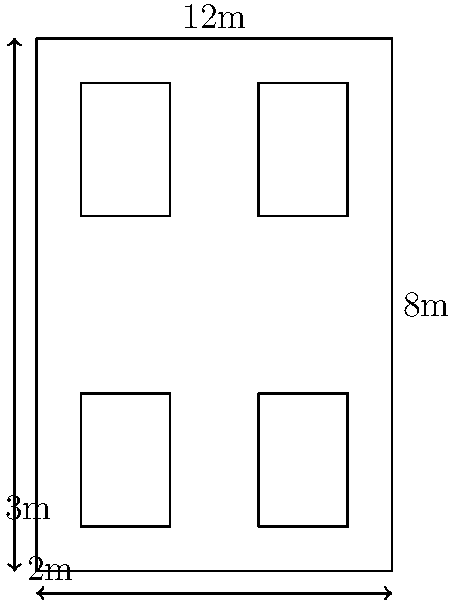A rectangular kitchen measures 8m by 12m. You need to place four identical rectangular workstations, each measuring 2m by 3m. What is the maximum possible distance between the centers of any two workstations, assuming they are placed parallel to the kitchen walls and at least 1m away from any wall? To solve this problem, we'll follow these steps:

1) First, we need to understand the constraints:
   - Kitchen dimensions: 8m x 12m
   - Workstation dimensions: 2m x 3m
   - Minimum distance from walls: 1m

2) Given these constraints, the workstations can be placed in the following coordinates:
   - Workstation 1: (1,1) to (3,4)
   - Workstation 2: (5,1) to (7,4)
   - Workstation 3: (1,8) to (3,11)
   - Workstation 4: (5,8) to (7,11)

3) The centers of these workstations will be at:
   - C1: (2,2.5)
   - C2: (6,2.5)
   - C3: (2,9.5)
   - C4: (6,9.5)

4) To find the maximum distance, we need to calculate the distance between the farthest points. This will be either C1 to C4 or C2 to C3.

5) We can use the distance formula: $d = \sqrt{(x_2-x_1)^2 + (y_2-y_1)^2}$

6) For C1 to C4:
   $d = \sqrt{(6-2)^2 + (9.5-2.5)^2} = \sqrt{4^2 + 7^2} = \sqrt{16 + 49} = \sqrt{65} = 8.06$ m

7) For C2 to C3:
   $d = \sqrt{(2-6)^2 + (9.5-2.5)^2} = \sqrt{(-4)^2 + 7^2} = \sqrt{16 + 49} = \sqrt{65} = 8.06$ m

8) Both distances are the same, so the maximum distance is 8.06 m.
Answer: 8.06 m 